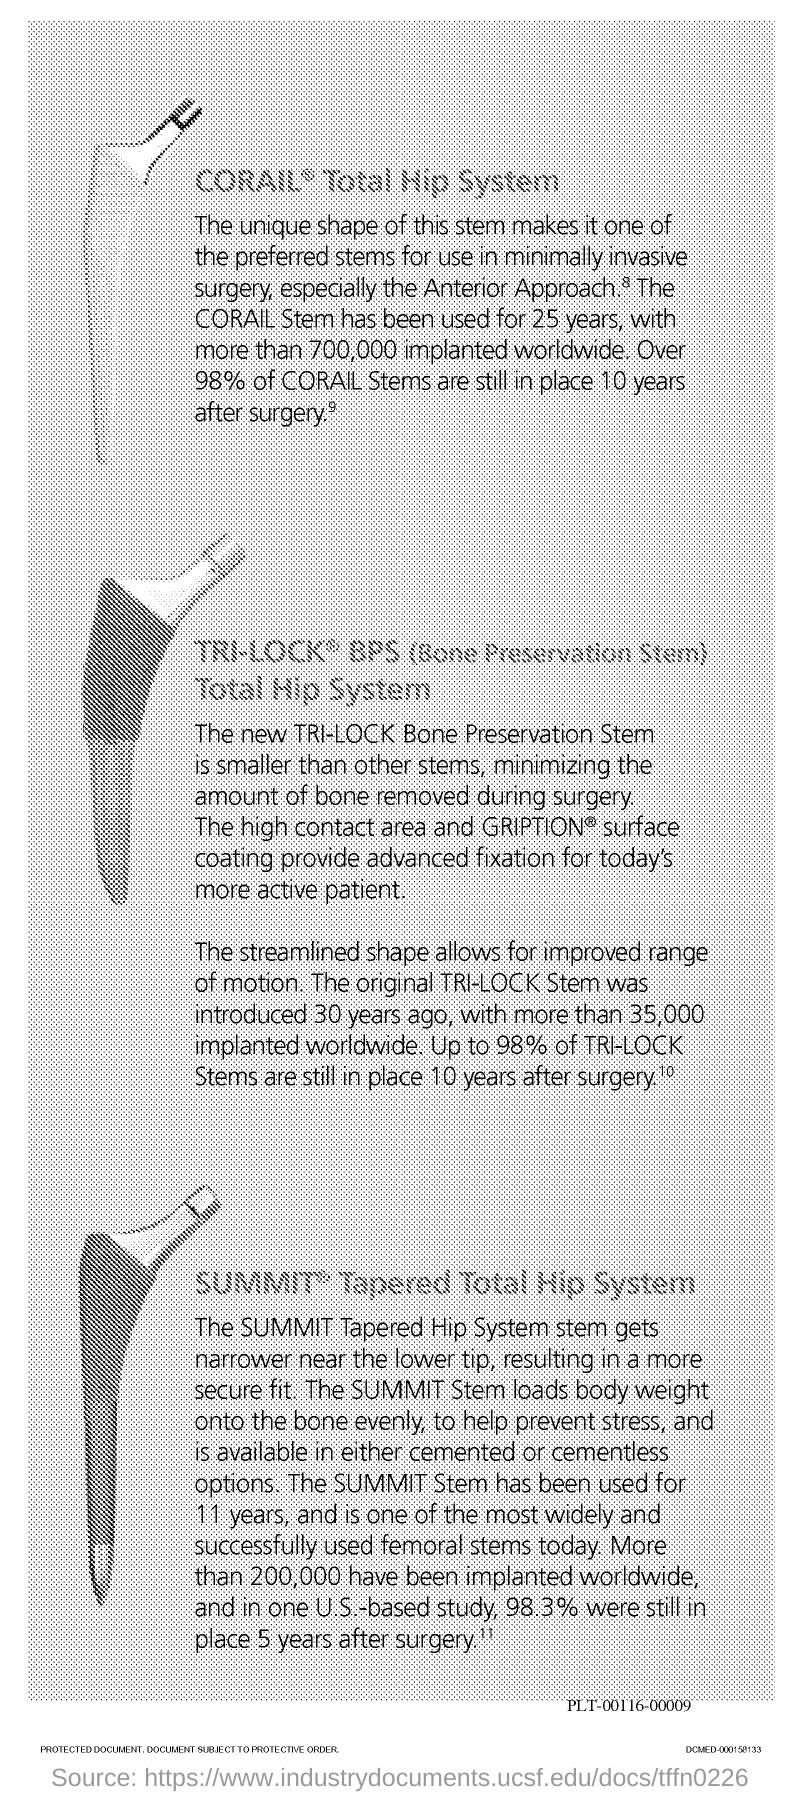How long has The CORAIL Stem been used?
Your answer should be compact. 25 years. How many has been implanted worldwide?
Make the answer very short. 700,000. How many CORAIL Stems are in place?
Make the answer very short. 98%. 